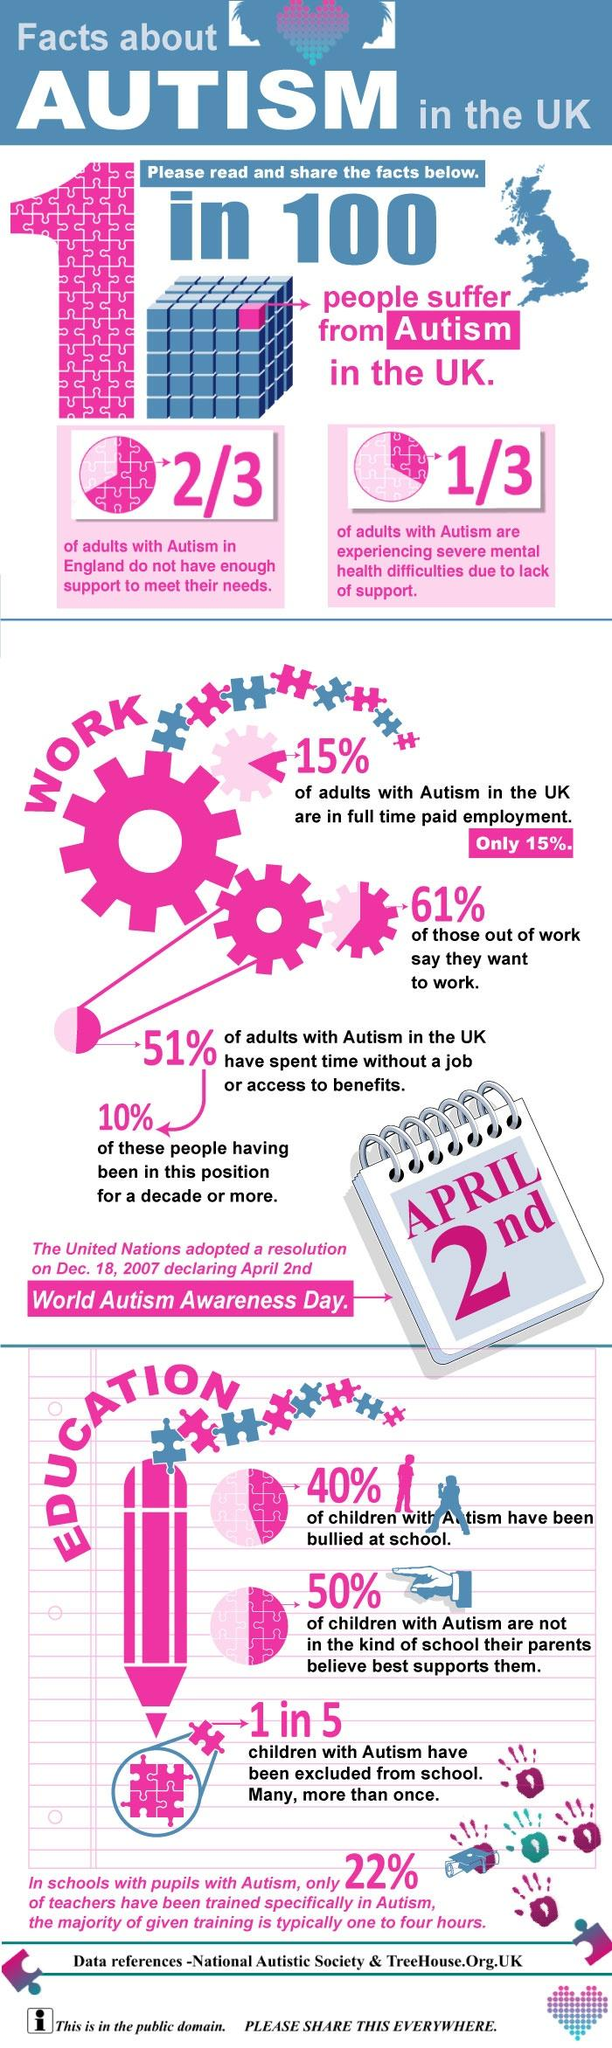Draw attention to some important aspects in this diagram. According to studies, approximately 20% of autistic children have been excluded from school. A recent study found that 40% of autistic students have been bullied in school. There is one pink cube on the Rubik's cube. In the United Kingdom, 15% of autistic adults hold full-time jobs. In the UK, one out of every hundred individuals is affected by autism, a mental disorder characterized by difficulty in social interaction and communication. 